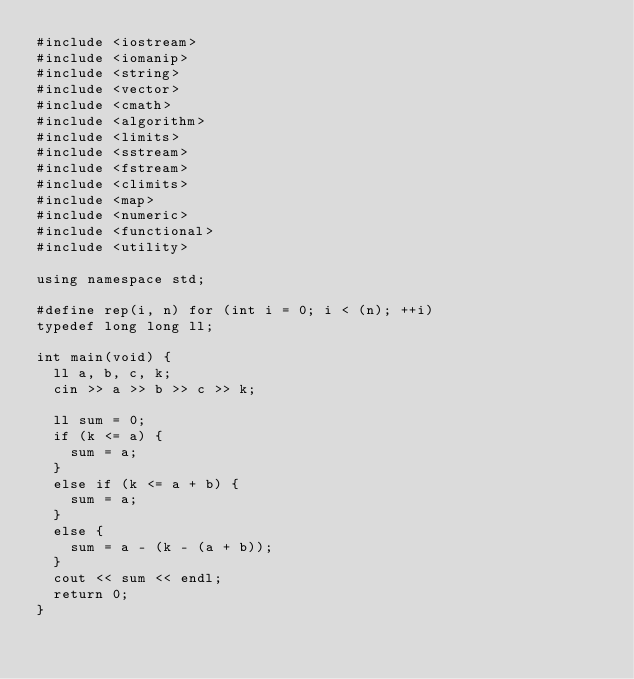<code> <loc_0><loc_0><loc_500><loc_500><_C++_>#include <iostream>
#include <iomanip>
#include <string>
#include <vector>
#include <cmath>
#include <algorithm>
#include <limits>
#include <sstream>
#include <fstream>
#include <climits>
#include <map>
#include <numeric>
#include <functional>
#include <utility>

using namespace std;

#define rep(i, n) for (int i = 0; i < (n); ++i)
typedef long long ll;

int main(void) {
  ll a, b, c, k;
  cin >> a >> b >> c >> k;

  ll sum = 0;
  if (k <= a) {
    sum = a;
  }
  else if (k <= a + b) {
    sum = a;
  }
  else {
    sum = a - (k - (a + b));
  }
  cout << sum << endl;
  return 0;
}
</code> 